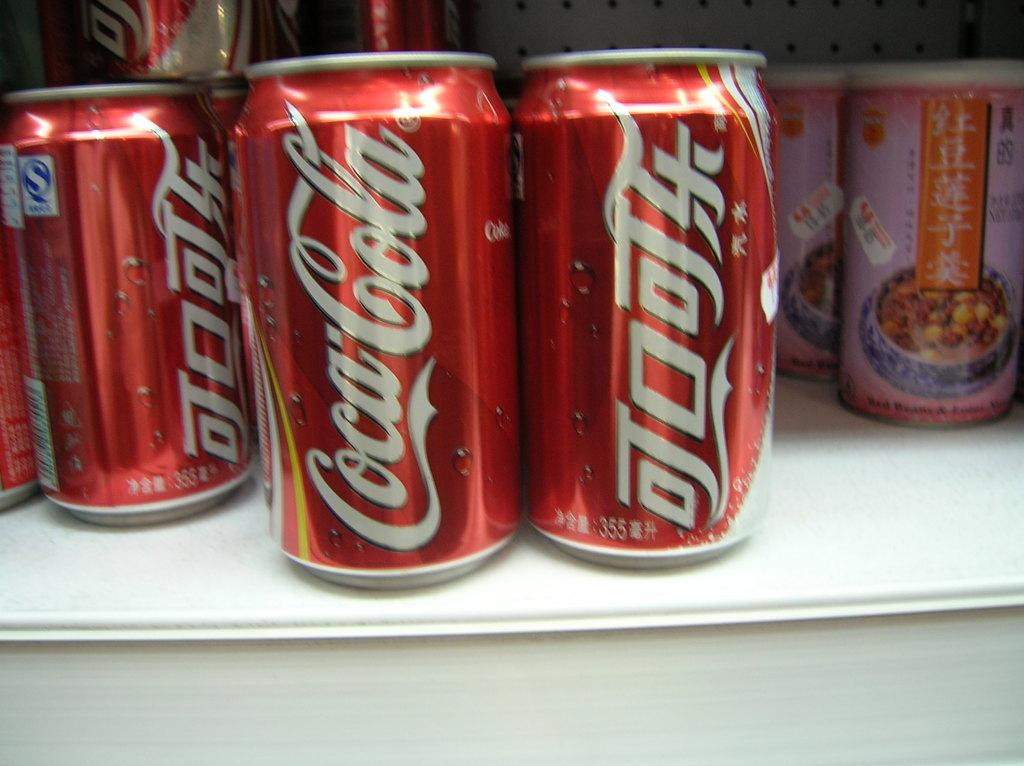Provide a one-sentence caption for the provided image. Cans of coca cola on a shelf next to chinese food. 